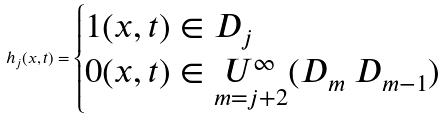Convert formula to latex. <formula><loc_0><loc_0><loc_500><loc_500>h _ { j } ( x , t ) = \begin{cases} 1 ( x , t ) \in D _ { j } \\ 0 ( x , t ) \in \underset { m = j + 2 } { U ^ { \infty } } ( D _ { m } \ D _ { m - 1 } ) \end{cases}</formula> 